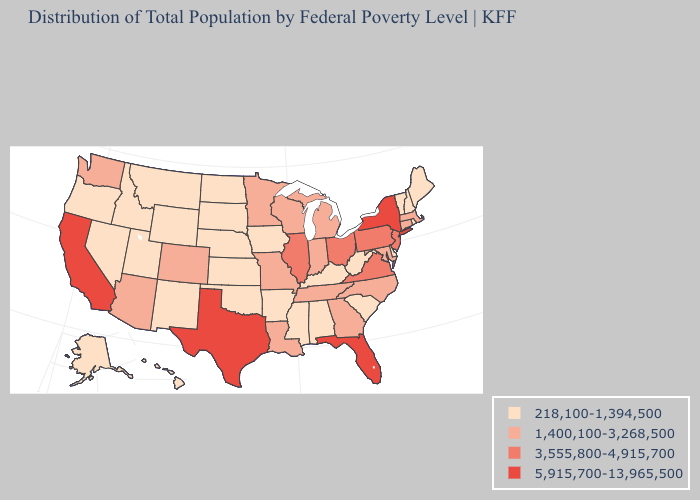Does West Virginia have a lower value than Nevada?
Concise answer only. No. Does California have the highest value in the West?
Concise answer only. Yes. Among the states that border Nevada , which have the highest value?
Answer briefly. California. What is the value of Oklahoma?
Quick response, please. 218,100-1,394,500. What is the highest value in the West ?
Concise answer only. 5,915,700-13,965,500. Name the states that have a value in the range 218,100-1,394,500?
Keep it brief. Alabama, Alaska, Arkansas, Delaware, Hawaii, Idaho, Iowa, Kansas, Kentucky, Maine, Mississippi, Montana, Nebraska, Nevada, New Hampshire, New Mexico, North Dakota, Oklahoma, Oregon, Rhode Island, South Carolina, South Dakota, Utah, Vermont, West Virginia, Wyoming. What is the highest value in the MidWest ?
Short answer required. 3,555,800-4,915,700. What is the value of West Virginia?
Answer briefly. 218,100-1,394,500. What is the lowest value in the South?
Answer briefly. 218,100-1,394,500. What is the value of Massachusetts?
Keep it brief. 1,400,100-3,268,500. Name the states that have a value in the range 1,400,100-3,268,500?
Short answer required. Arizona, Colorado, Connecticut, Georgia, Indiana, Louisiana, Maryland, Massachusetts, Michigan, Minnesota, Missouri, North Carolina, Tennessee, Washington, Wisconsin. Which states hav the highest value in the MidWest?
Keep it brief. Illinois, Ohio. Does South Carolina have the lowest value in the USA?
Give a very brief answer. Yes. What is the highest value in the West ?
Answer briefly. 5,915,700-13,965,500. 